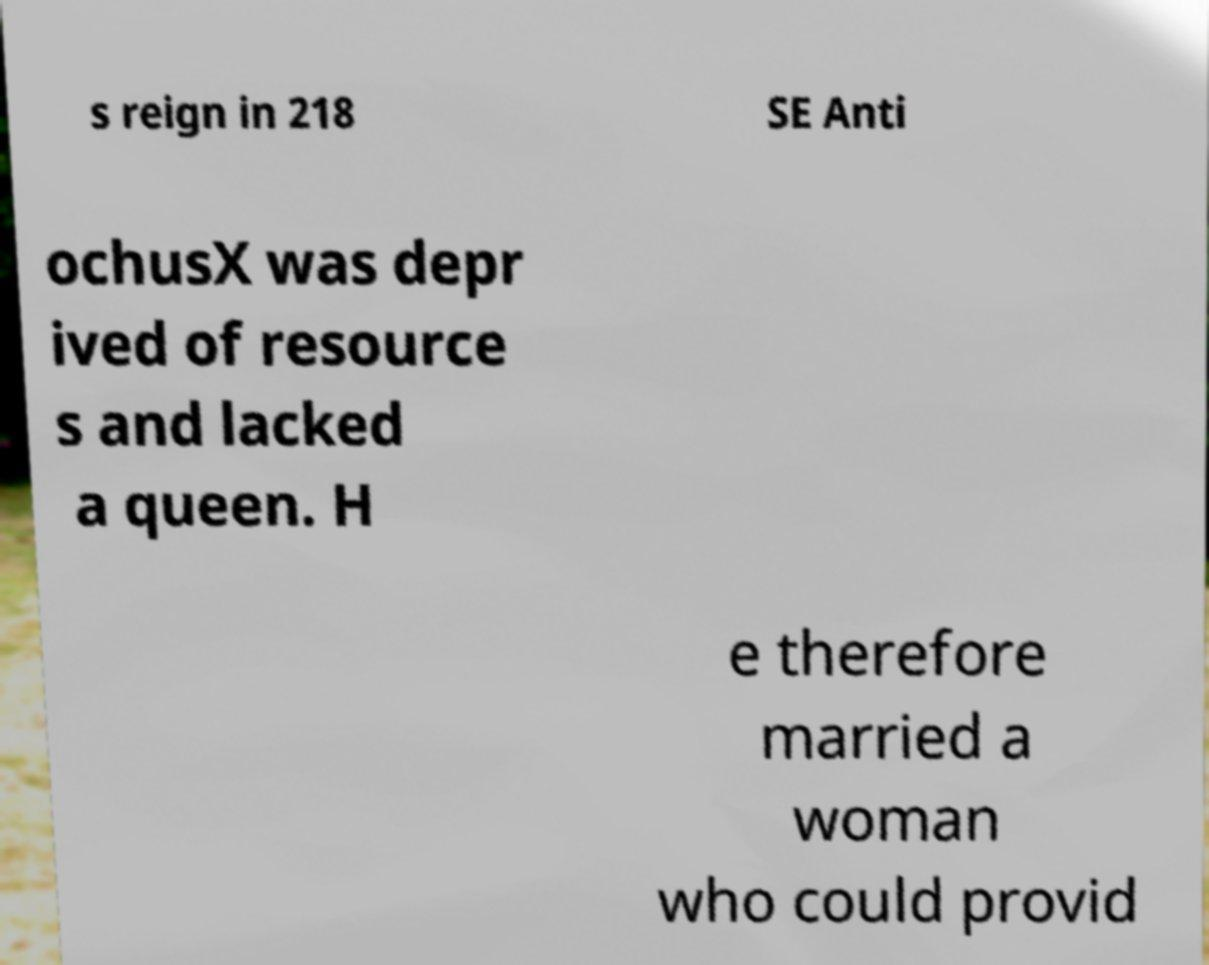Could you extract and type out the text from this image? s reign in 218 SE Anti ochusX was depr ived of resource s and lacked a queen. H e therefore married a woman who could provid 